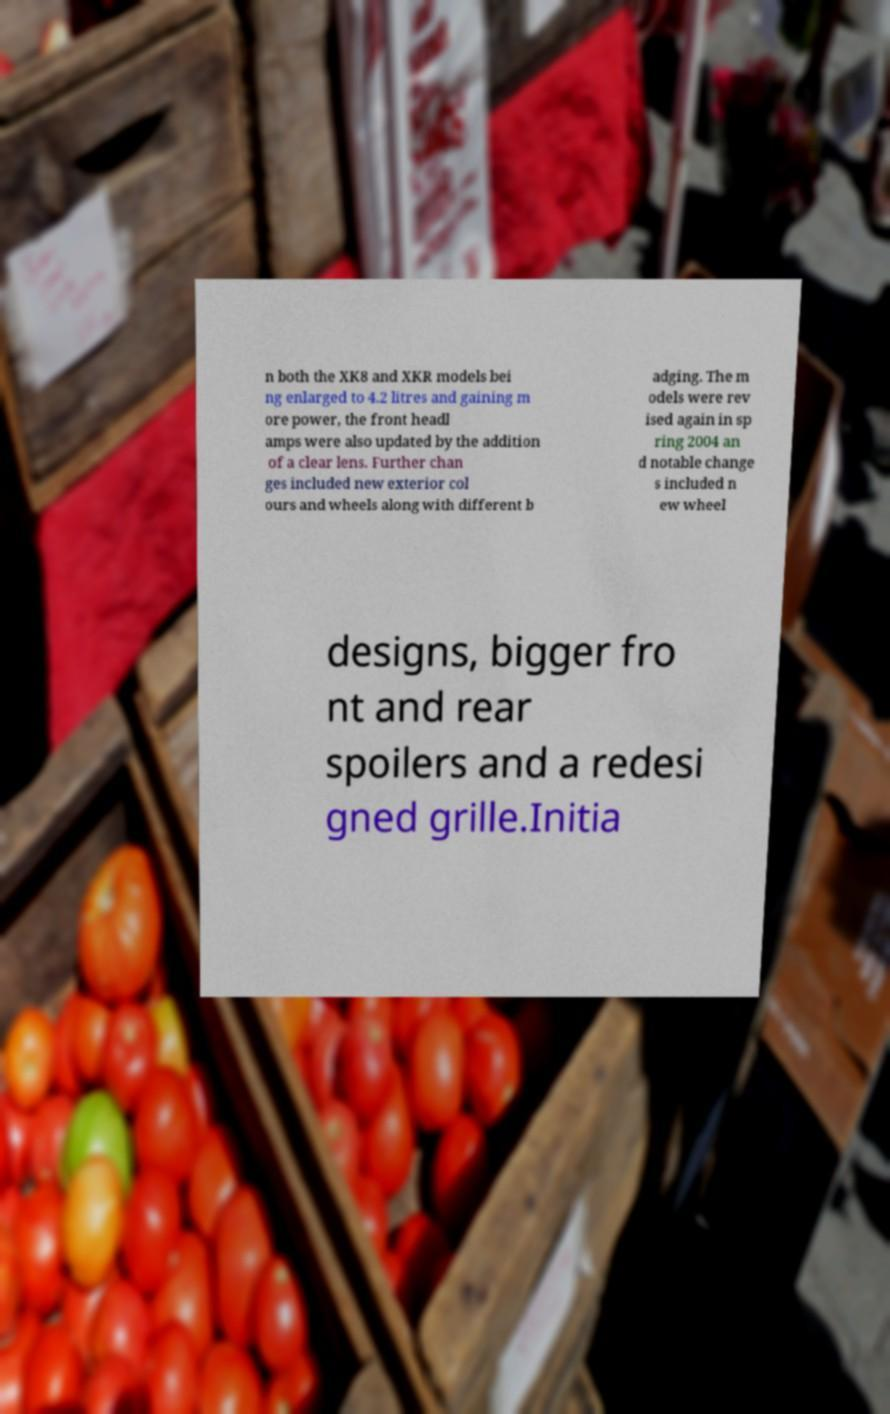Could you assist in decoding the text presented in this image and type it out clearly? n both the XK8 and XKR models bei ng enlarged to 4.2 litres and gaining m ore power, the front headl amps were also updated by the addition of a clear lens. Further chan ges included new exterior col ours and wheels along with different b adging. The m odels were rev ised again in sp ring 2004 an d notable change s included n ew wheel designs, bigger fro nt and rear spoilers and a redesi gned grille.Initia 